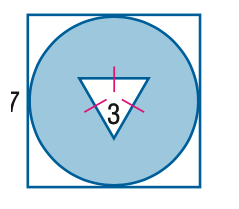Answer the mathemtical geometry problem and directly provide the correct option letter.
Question: Find the area of the shaded region. Round to the nearest tenth.
Choices: A: 26.8 B: 30.7 C: 31.7 D: 34.6 D 